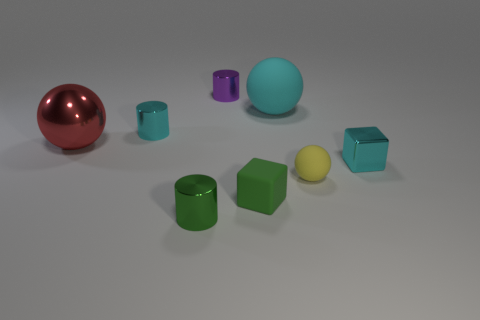Is there anything else that is the same size as the metal ball?
Your answer should be very brief. Yes. There is a shiny cylinder that is the same color as the big matte thing; what is its size?
Provide a succinct answer. Small. What color is the other rubber thing that is the same shape as the large matte object?
Ensure brevity in your answer.  Yellow. Do the large sphere left of the tiny purple metallic cylinder and the tiny matte ball have the same color?
Your answer should be compact. No. Is the purple cylinder the same size as the red object?
Your answer should be very brief. No. There is a purple thing that is made of the same material as the small cyan cylinder; what is its shape?
Your response must be concise. Cylinder. How many other things are there of the same shape as the big red metal thing?
Make the answer very short. 2. The cyan metallic thing that is in front of the cyan metal object behind the small cyan metallic thing that is in front of the red sphere is what shape?
Ensure brevity in your answer.  Cube. How many blocks are either small shiny objects or purple shiny things?
Provide a succinct answer. 1. Is there a metallic thing on the right side of the shiny thing that is in front of the tiny cyan metallic block?
Keep it short and to the point. Yes. 